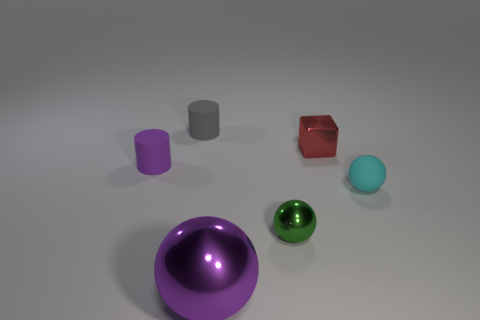Is the number of small objects that are on the right side of the small cyan matte sphere the same as the number of big metallic spheres that are right of the red metallic object?
Offer a very short reply. Yes. There is a matte thing that is in front of the purple cylinder; is its shape the same as the green metal thing?
Your response must be concise. Yes. What number of red things are either small metal blocks or small matte spheres?
Keep it short and to the point. 1. There is a big object that is the same shape as the tiny green object; what material is it?
Offer a very short reply. Metal. There is a tiny thing that is behind the block; what shape is it?
Your answer should be compact. Cylinder. Is there another purple object that has the same material as the tiny purple thing?
Your answer should be compact. No. Do the purple matte thing and the cyan rubber thing have the same size?
Ensure brevity in your answer.  Yes. How many spheres are big yellow objects or gray matte things?
Ensure brevity in your answer.  0. What material is the small cylinder that is the same color as the large metallic thing?
Make the answer very short. Rubber. How many large purple things are the same shape as the tiny cyan object?
Make the answer very short. 1. 